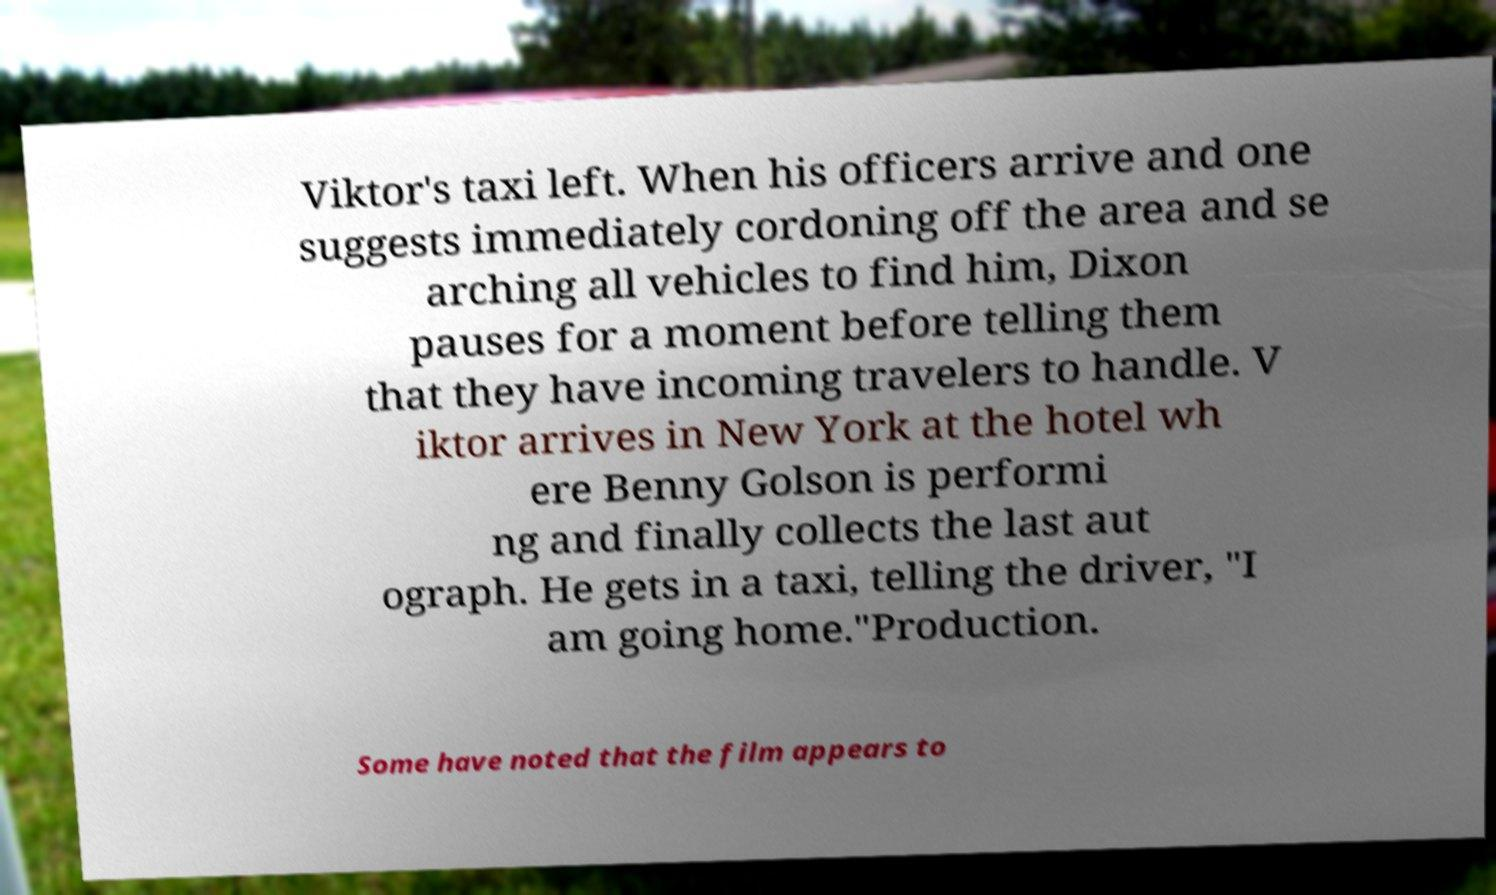What messages or text are displayed in this image? I need them in a readable, typed format. Viktor's taxi left. When his officers arrive and one suggests immediately cordoning off the area and se arching all vehicles to find him, Dixon pauses for a moment before telling them that they have incoming travelers to handle. V iktor arrives in New York at the hotel wh ere Benny Golson is performi ng and finally collects the last aut ograph. He gets in a taxi, telling the driver, "I am going home."Production. Some have noted that the film appears to 